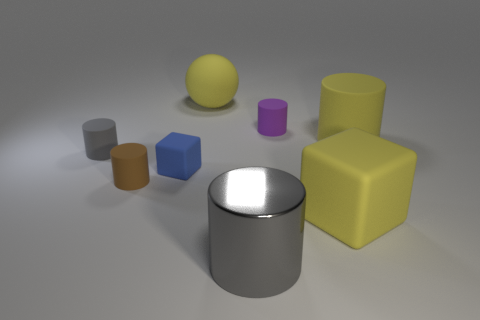Subtract all brown cylinders. How many cylinders are left? 4 Subtract all small brown cylinders. How many cylinders are left? 4 Subtract all red cylinders. Subtract all green balls. How many cylinders are left? 5 Add 1 tiny gray shiny cylinders. How many objects exist? 9 Subtract all blocks. How many objects are left? 6 Add 4 yellow matte cylinders. How many yellow matte cylinders exist? 5 Subtract 0 red spheres. How many objects are left? 8 Subtract all yellow balls. Subtract all yellow rubber spheres. How many objects are left? 6 Add 2 small blue rubber things. How many small blue rubber things are left? 3 